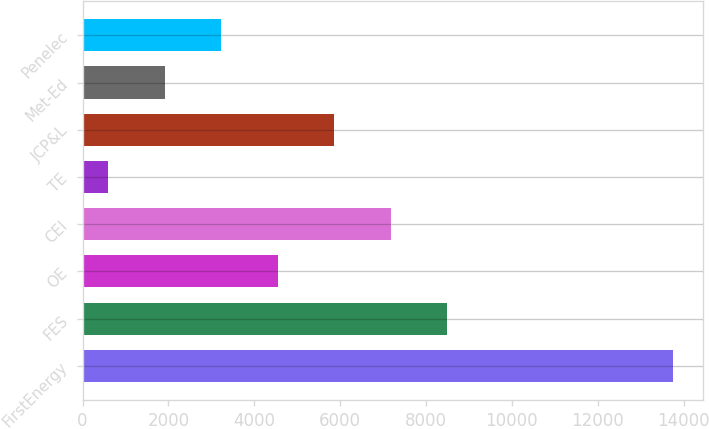Convert chart to OTSL. <chart><loc_0><loc_0><loc_500><loc_500><bar_chart><fcel>FirstEnergy<fcel>FES<fcel>OE<fcel>CEI<fcel>TE<fcel>JCP&L<fcel>Met-Ed<fcel>Penelec<nl><fcel>13753<fcel>8491.8<fcel>4545.9<fcel>7176.5<fcel>600<fcel>5861.2<fcel>1915.3<fcel>3230.6<nl></chart> 